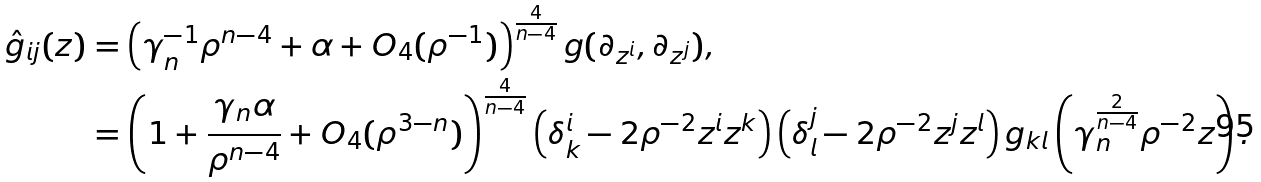Convert formula to latex. <formula><loc_0><loc_0><loc_500><loc_500>\hat { g } _ { i j } ( z ) & = \left ( \gamma ^ { - 1 } _ { n } \rho ^ { n - 4 } + \alpha + O _ { 4 } ( \rho ^ { - 1 } ) \right ) ^ { \frac { 4 } { n - 4 } } g ( \partial _ { z ^ { i } } , \partial _ { z ^ { j } } ) , \\ & = \left ( 1 + \frac { \gamma _ { n } \alpha } { \rho ^ { n - 4 } } + O _ { 4 } ( \rho ^ { 3 - n } ) \right ) ^ { \frac { 4 } { n - 4 } } \left ( \delta ^ { i } _ { k } - 2 \rho ^ { - 2 } z ^ { i } z ^ { k } \right ) \left ( \delta ^ { j } _ { l } - 2 \rho ^ { - 2 } z ^ { j } z ^ { l } \right ) g _ { k l } \left ( \gamma _ { n } ^ { \frac { 2 } { n - 4 } } \rho ^ { - 2 } z \right ) .</formula> 